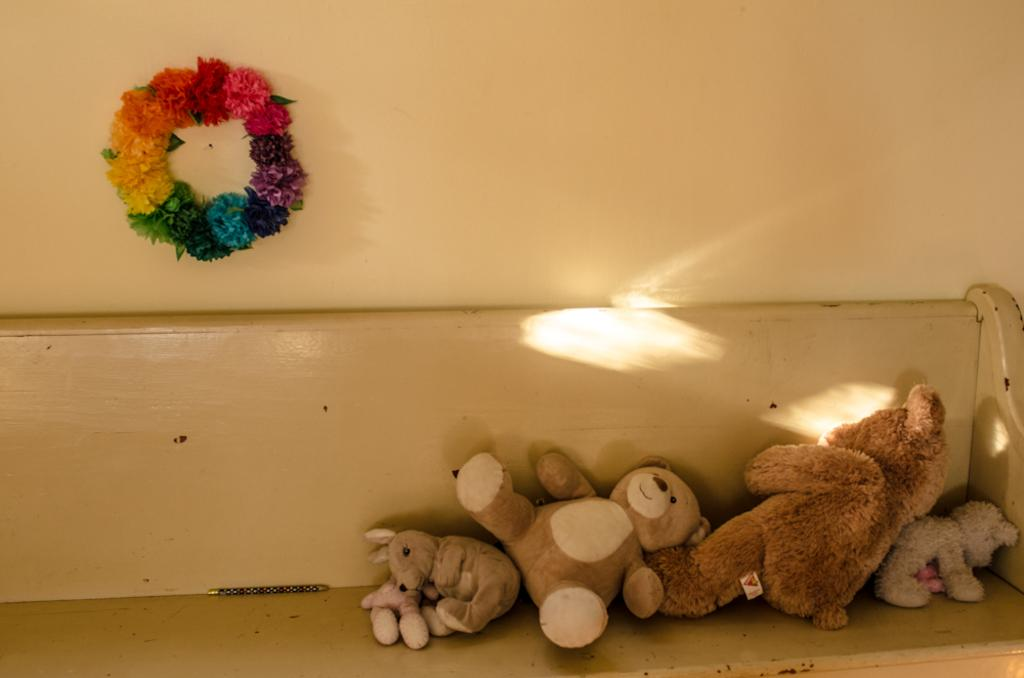What type of stuffed animals are in the image? There are teddy bears in the image. What other items can be seen in the image? There are toys in the image. Where are the teddy bears and toys located? The teddy bears and toys are on a bench. What decorative item is present in the image? There is a colorful wreath in the image. How is the wreath attached in the image? The wreath is attached to a wall. Can you see a kitty balancing on the stocking in the image? There is no kitty or stocking present in the image. 